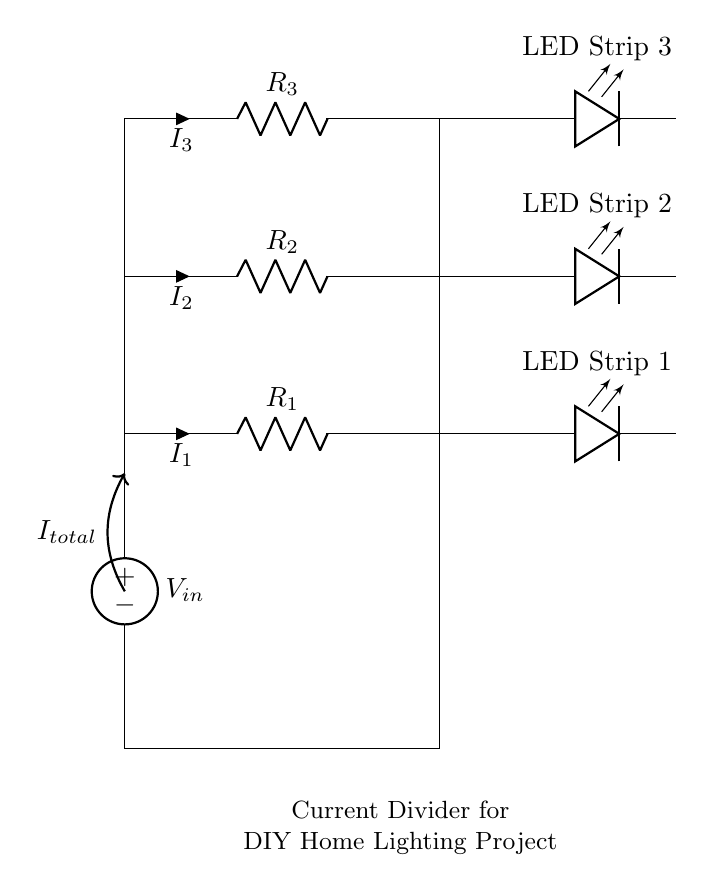What is the total current entering the circuit? The total current is represented by the label I total, which is indicated in the circuit diagram as the sum of the currents through the resistors and LED strips.
Answer: I total What type of circuit is this? This is a current divider circuit, evident from the multiple branches that distribute the input current into separate paths leading to the LED strips.
Answer: Current divider How many LED strips are connected in this circuit? The circuit diagram shows three distinct LED strips connected in parallel, each fed from a current branch.
Answer: Three What is the current through R2? The current through R2 is labeled as I2 in the circuit, which represents the amount of current passing through that resistor specifically.
Answer: I2 What role do the resistors play in this circuit? The resistors serve to divide the total input current into smaller currents for each LED strip, with the values of the resistors determining the proportion of current through each strip.
Answer: Current division How is the voltage source connected in the circuit? The voltage source is connected at the top of the circuit, providing a potential difference that drives the total current down through the resistors and ultimately to the LED strips.
Answer: At the top What does the label LED strip 1 represent? The label LED strip 1 indicates one of the output paths where the current is directed to power the first LED strip in the circuit.
Answer: First LED strip 